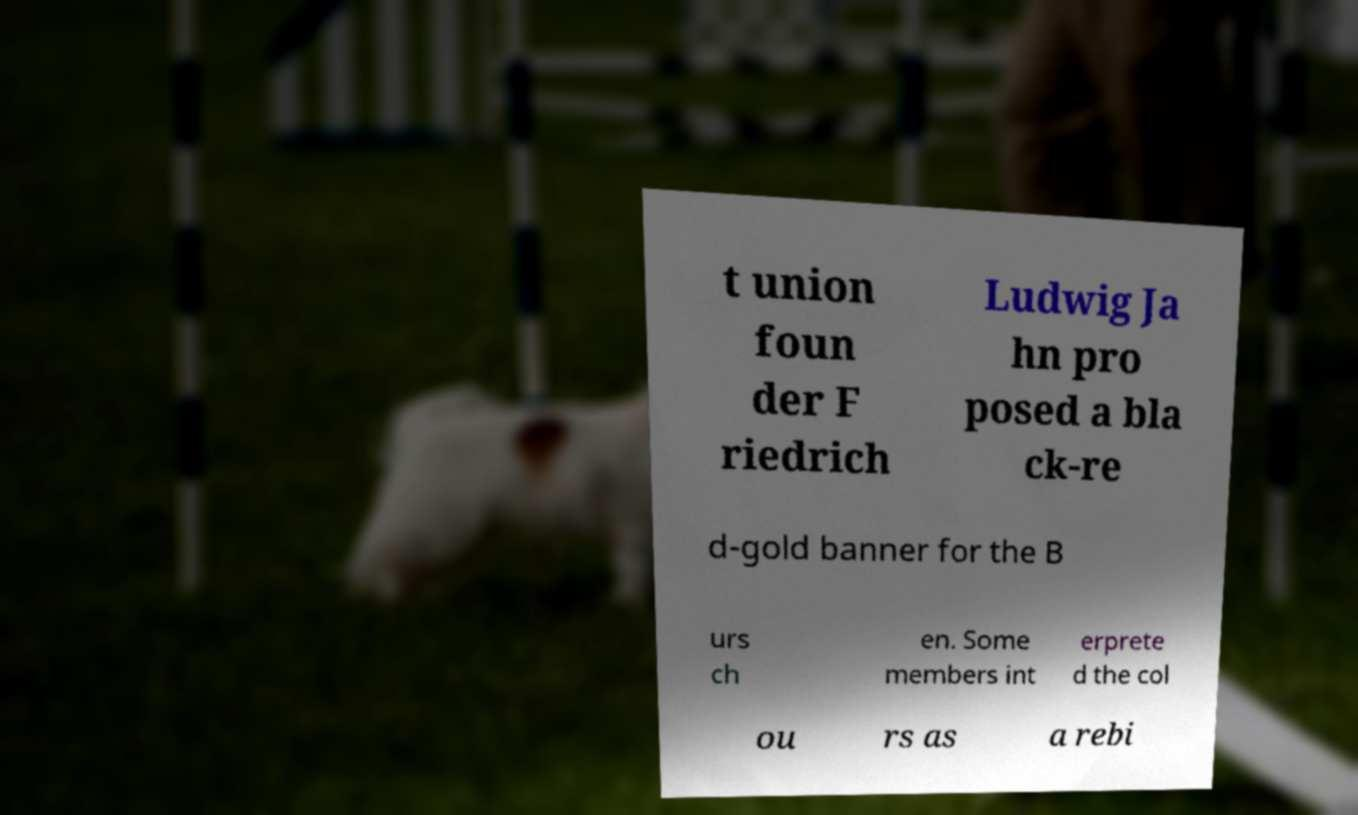What messages or text are displayed in this image? I need them in a readable, typed format. t union foun der F riedrich Ludwig Ja hn pro posed a bla ck-re d-gold banner for the B urs ch en. Some members int erprete d the col ou rs as a rebi 